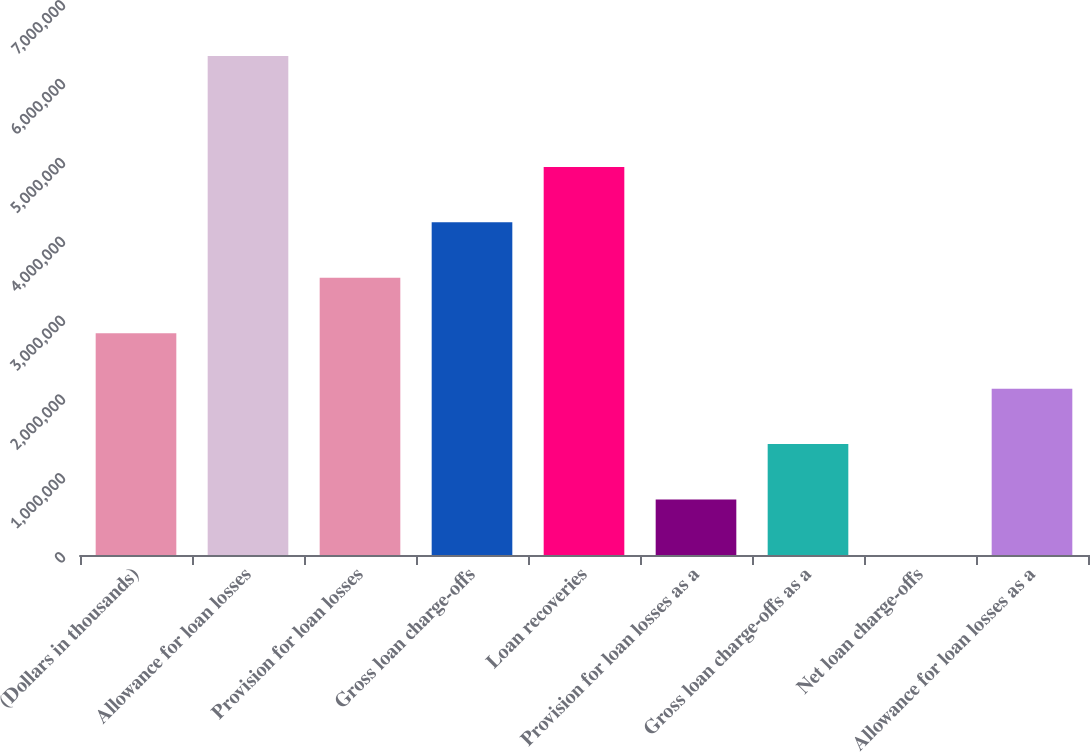Convert chart to OTSL. <chart><loc_0><loc_0><loc_500><loc_500><bar_chart><fcel>(Dollars in thousands)<fcel>Allowance for loan losses<fcel>Provision for loan losses<fcel>Gross loan charge-offs<fcel>Loan recoveries<fcel>Provision for loan losses as a<fcel>Gross loan charge-offs as a<fcel>Net loan charge-offs<fcel>Allowance for loan losses as a<nl><fcel>2.81213e+06<fcel>6.32729e+06<fcel>3.51516e+06<fcel>4.21819e+06<fcel>4.92122e+06<fcel>703032<fcel>1.40606e+06<fcel>0.02<fcel>2.1091e+06<nl></chart> 